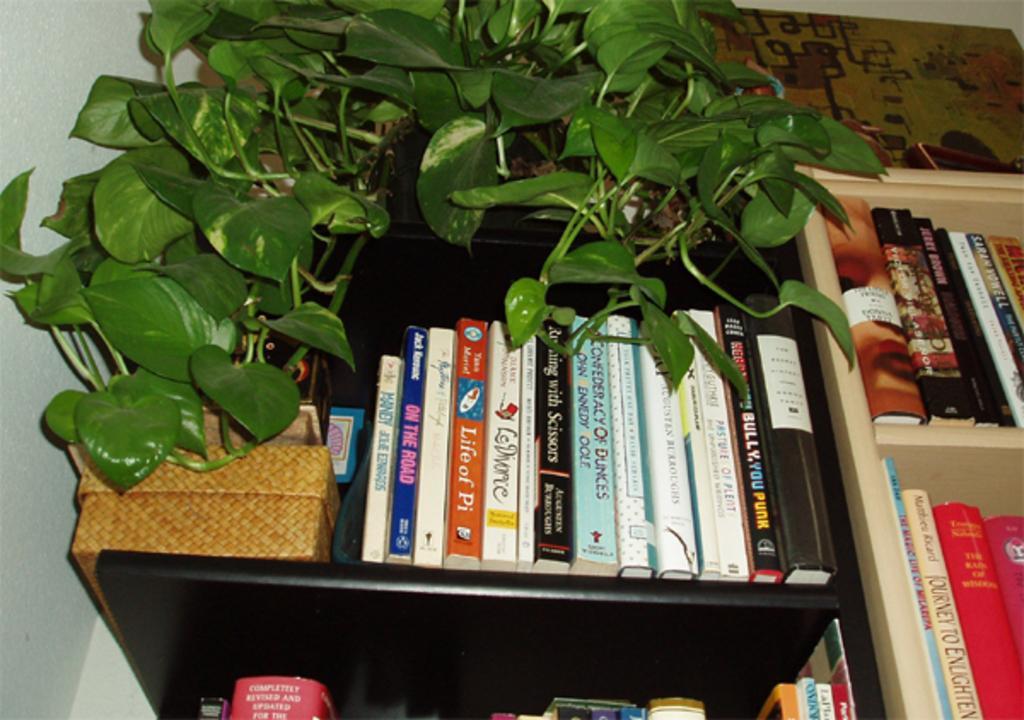How would you summarize this image in a sentence or two? In the center of the image there are books arranged in a rack. There is a money plant. To the left side of the image there is wall. 